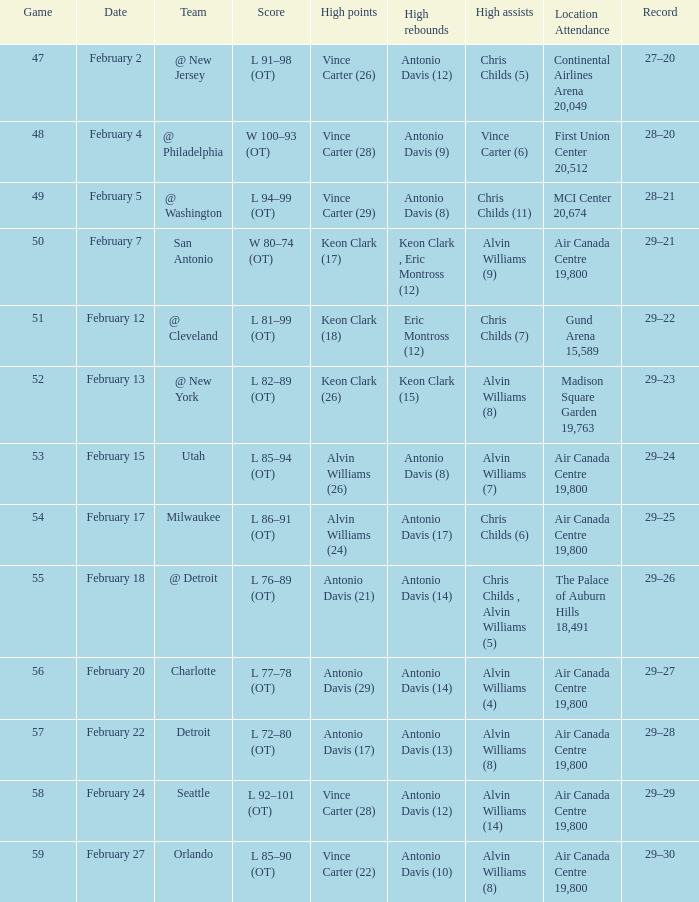What is the Record when the high rebounds was Antonio Davis (9)? 28–20. 